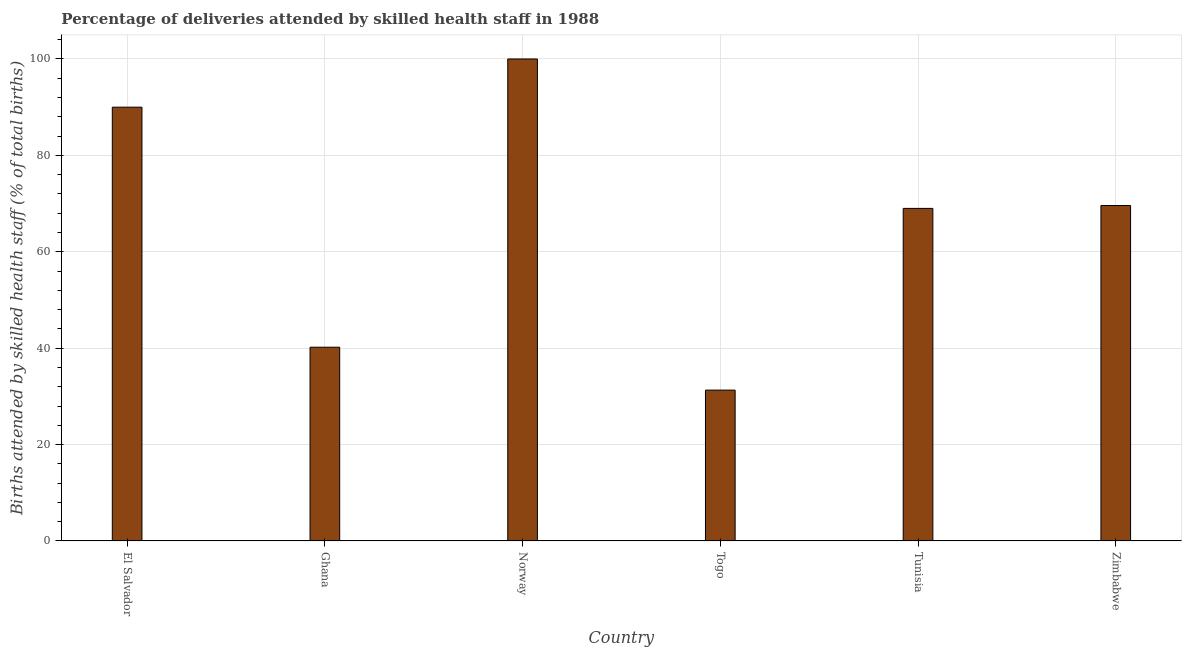What is the title of the graph?
Your answer should be compact. Percentage of deliveries attended by skilled health staff in 1988. What is the label or title of the Y-axis?
Keep it short and to the point. Births attended by skilled health staff (% of total births). What is the number of births attended by skilled health staff in Zimbabwe?
Your answer should be compact. 69.6. Across all countries, what is the maximum number of births attended by skilled health staff?
Ensure brevity in your answer.  100. Across all countries, what is the minimum number of births attended by skilled health staff?
Offer a very short reply. 31.3. In which country was the number of births attended by skilled health staff minimum?
Make the answer very short. Togo. What is the sum of the number of births attended by skilled health staff?
Offer a very short reply. 400.1. What is the difference between the number of births attended by skilled health staff in Norway and Tunisia?
Give a very brief answer. 31. What is the average number of births attended by skilled health staff per country?
Offer a terse response. 66.68. What is the median number of births attended by skilled health staff?
Provide a short and direct response. 69.3. In how many countries, is the number of births attended by skilled health staff greater than 72 %?
Offer a very short reply. 2. What is the ratio of the number of births attended by skilled health staff in El Salvador to that in Tunisia?
Your answer should be compact. 1.3. Is the number of births attended by skilled health staff in Ghana less than that in Tunisia?
Provide a short and direct response. Yes. What is the difference between the highest and the second highest number of births attended by skilled health staff?
Give a very brief answer. 10. Is the sum of the number of births attended by skilled health staff in El Salvador and Tunisia greater than the maximum number of births attended by skilled health staff across all countries?
Provide a succinct answer. Yes. What is the difference between the highest and the lowest number of births attended by skilled health staff?
Provide a succinct answer. 68.7. How many countries are there in the graph?
Offer a very short reply. 6. What is the Births attended by skilled health staff (% of total births) in Ghana?
Ensure brevity in your answer.  40.2. What is the Births attended by skilled health staff (% of total births) of Togo?
Provide a succinct answer. 31.3. What is the Births attended by skilled health staff (% of total births) in Zimbabwe?
Provide a short and direct response. 69.6. What is the difference between the Births attended by skilled health staff (% of total births) in El Salvador and Ghana?
Your answer should be compact. 49.8. What is the difference between the Births attended by skilled health staff (% of total births) in El Salvador and Togo?
Keep it short and to the point. 58.7. What is the difference between the Births attended by skilled health staff (% of total births) in El Salvador and Tunisia?
Offer a terse response. 21. What is the difference between the Births attended by skilled health staff (% of total births) in El Salvador and Zimbabwe?
Your response must be concise. 20.4. What is the difference between the Births attended by skilled health staff (% of total births) in Ghana and Norway?
Provide a succinct answer. -59.8. What is the difference between the Births attended by skilled health staff (% of total births) in Ghana and Togo?
Your response must be concise. 8.9. What is the difference between the Births attended by skilled health staff (% of total births) in Ghana and Tunisia?
Your response must be concise. -28.8. What is the difference between the Births attended by skilled health staff (% of total births) in Ghana and Zimbabwe?
Provide a succinct answer. -29.4. What is the difference between the Births attended by skilled health staff (% of total births) in Norway and Togo?
Your answer should be compact. 68.7. What is the difference between the Births attended by skilled health staff (% of total births) in Norway and Zimbabwe?
Give a very brief answer. 30.4. What is the difference between the Births attended by skilled health staff (% of total births) in Togo and Tunisia?
Ensure brevity in your answer.  -37.7. What is the difference between the Births attended by skilled health staff (% of total births) in Togo and Zimbabwe?
Offer a very short reply. -38.3. What is the difference between the Births attended by skilled health staff (% of total births) in Tunisia and Zimbabwe?
Give a very brief answer. -0.6. What is the ratio of the Births attended by skilled health staff (% of total births) in El Salvador to that in Ghana?
Your answer should be compact. 2.24. What is the ratio of the Births attended by skilled health staff (% of total births) in El Salvador to that in Togo?
Provide a short and direct response. 2.88. What is the ratio of the Births attended by skilled health staff (% of total births) in El Salvador to that in Tunisia?
Your answer should be compact. 1.3. What is the ratio of the Births attended by skilled health staff (% of total births) in El Salvador to that in Zimbabwe?
Offer a terse response. 1.29. What is the ratio of the Births attended by skilled health staff (% of total births) in Ghana to that in Norway?
Keep it short and to the point. 0.4. What is the ratio of the Births attended by skilled health staff (% of total births) in Ghana to that in Togo?
Offer a very short reply. 1.28. What is the ratio of the Births attended by skilled health staff (% of total births) in Ghana to that in Tunisia?
Your answer should be compact. 0.58. What is the ratio of the Births attended by skilled health staff (% of total births) in Ghana to that in Zimbabwe?
Give a very brief answer. 0.58. What is the ratio of the Births attended by skilled health staff (% of total births) in Norway to that in Togo?
Your answer should be compact. 3.19. What is the ratio of the Births attended by skilled health staff (% of total births) in Norway to that in Tunisia?
Make the answer very short. 1.45. What is the ratio of the Births attended by skilled health staff (% of total births) in Norway to that in Zimbabwe?
Provide a succinct answer. 1.44. What is the ratio of the Births attended by skilled health staff (% of total births) in Togo to that in Tunisia?
Keep it short and to the point. 0.45. What is the ratio of the Births attended by skilled health staff (% of total births) in Togo to that in Zimbabwe?
Make the answer very short. 0.45. 